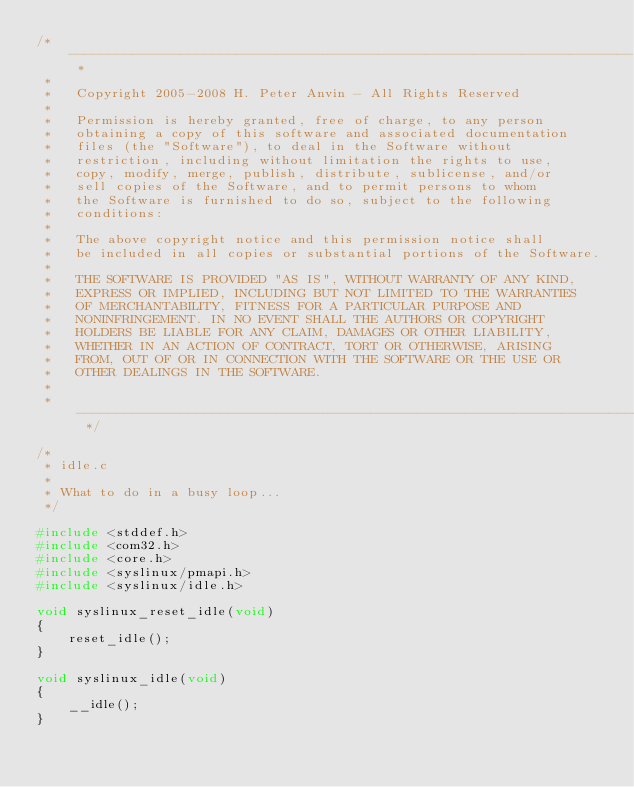<code> <loc_0><loc_0><loc_500><loc_500><_C_>/* ----------------------------------------------------------------------- *
 *
 *   Copyright 2005-2008 H. Peter Anvin - All Rights Reserved
 *
 *   Permission is hereby granted, free of charge, to any person
 *   obtaining a copy of this software and associated documentation
 *   files (the "Software"), to deal in the Software without
 *   restriction, including without limitation the rights to use,
 *   copy, modify, merge, publish, distribute, sublicense, and/or
 *   sell copies of the Software, and to permit persons to whom
 *   the Software is furnished to do so, subject to the following
 *   conditions:
 *
 *   The above copyright notice and this permission notice shall
 *   be included in all copies or substantial portions of the Software.
 *
 *   THE SOFTWARE IS PROVIDED "AS IS", WITHOUT WARRANTY OF ANY KIND,
 *   EXPRESS OR IMPLIED, INCLUDING BUT NOT LIMITED TO THE WARRANTIES
 *   OF MERCHANTABILITY, FITNESS FOR A PARTICULAR PURPOSE AND
 *   NONINFRINGEMENT. IN NO EVENT SHALL THE AUTHORS OR COPYRIGHT
 *   HOLDERS BE LIABLE FOR ANY CLAIM, DAMAGES OR OTHER LIABILITY,
 *   WHETHER IN AN ACTION OF CONTRACT, TORT OR OTHERWISE, ARISING
 *   FROM, OUT OF OR IN CONNECTION WITH THE SOFTWARE OR THE USE OR
 *   OTHER DEALINGS IN THE SOFTWARE.
 *
 * ----------------------------------------------------------------------- */

/*
 * idle.c
 *
 * What to do in a busy loop...
 */

#include <stddef.h>
#include <com32.h>
#include <core.h>
#include <syslinux/pmapi.h>
#include <syslinux/idle.h>

void syslinux_reset_idle(void)
{
    reset_idle();
}

void syslinux_idle(void)
{
    __idle();
}
</code> 